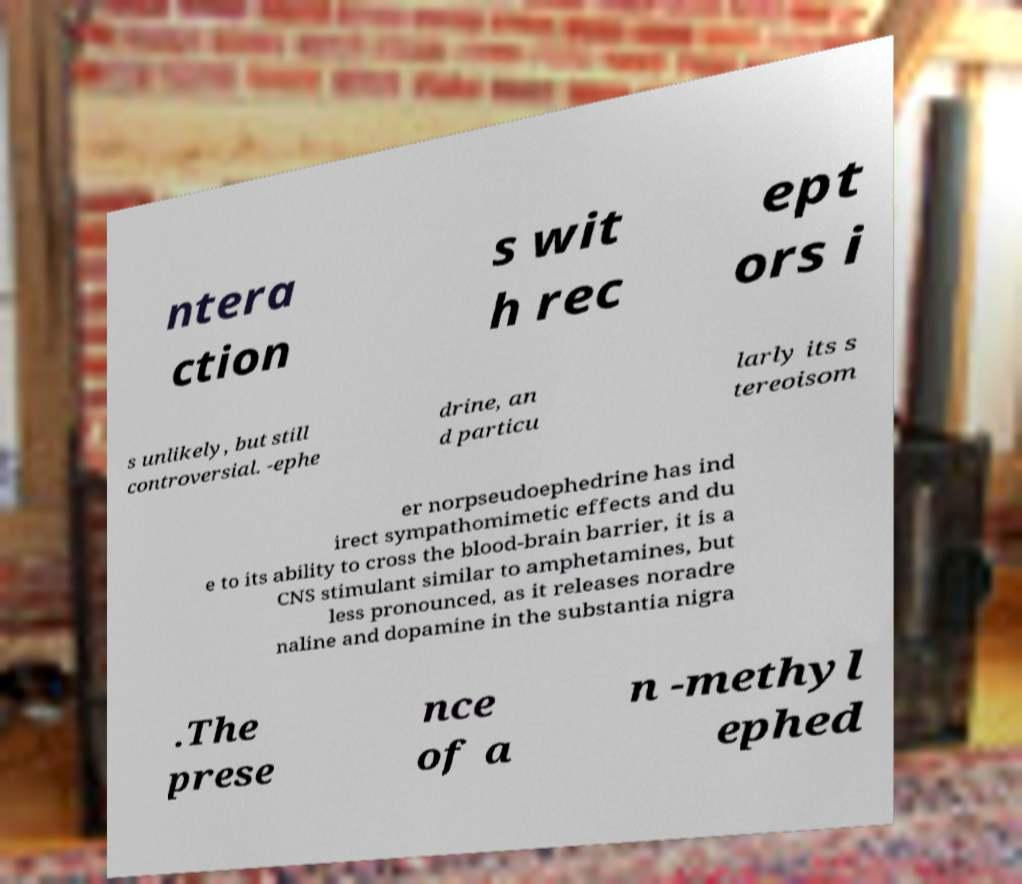Could you extract and type out the text from this image? ntera ction s wit h rec ept ors i s unlikely, but still controversial. -ephe drine, an d particu larly its s tereoisom er norpseudoephedrine has ind irect sympathomimetic effects and du e to its ability to cross the blood-brain barrier, it is a CNS stimulant similar to amphetamines, but less pronounced, as it releases noradre naline and dopamine in the substantia nigra .The prese nce of a n -methyl ephed 